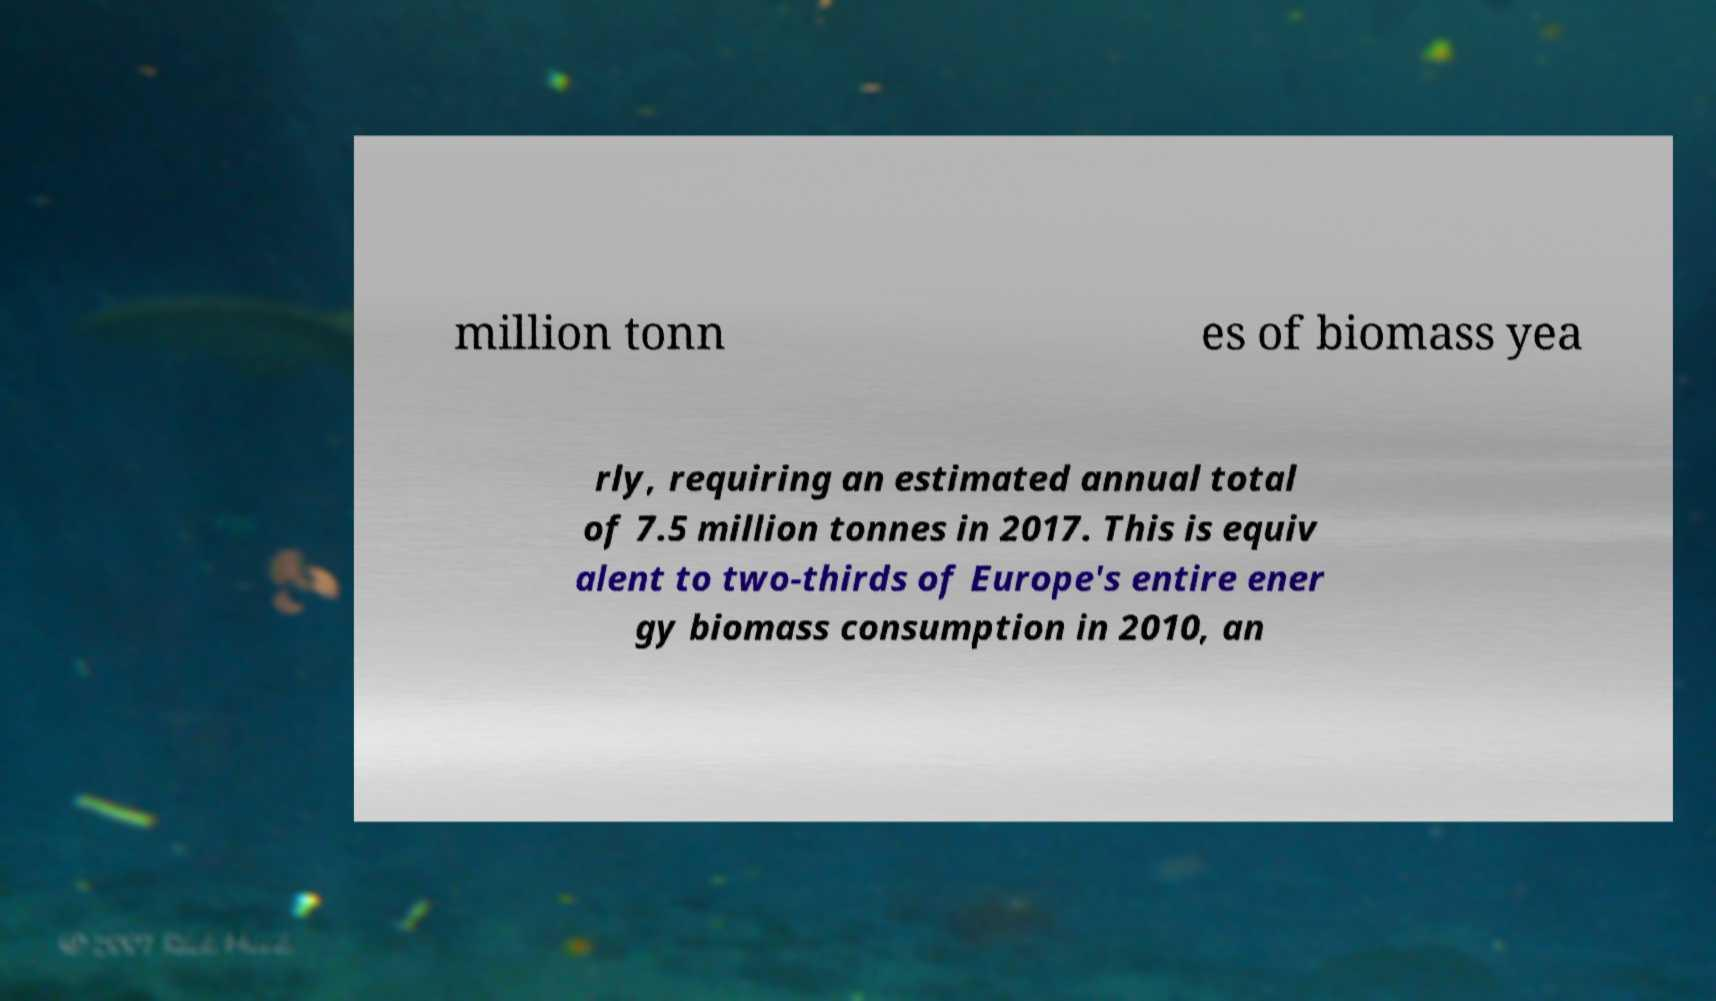Could you extract and type out the text from this image? million tonn es of biomass yea rly, requiring an estimated annual total of 7.5 million tonnes in 2017. This is equiv alent to two-thirds of Europe's entire ener gy biomass consumption in 2010, an 